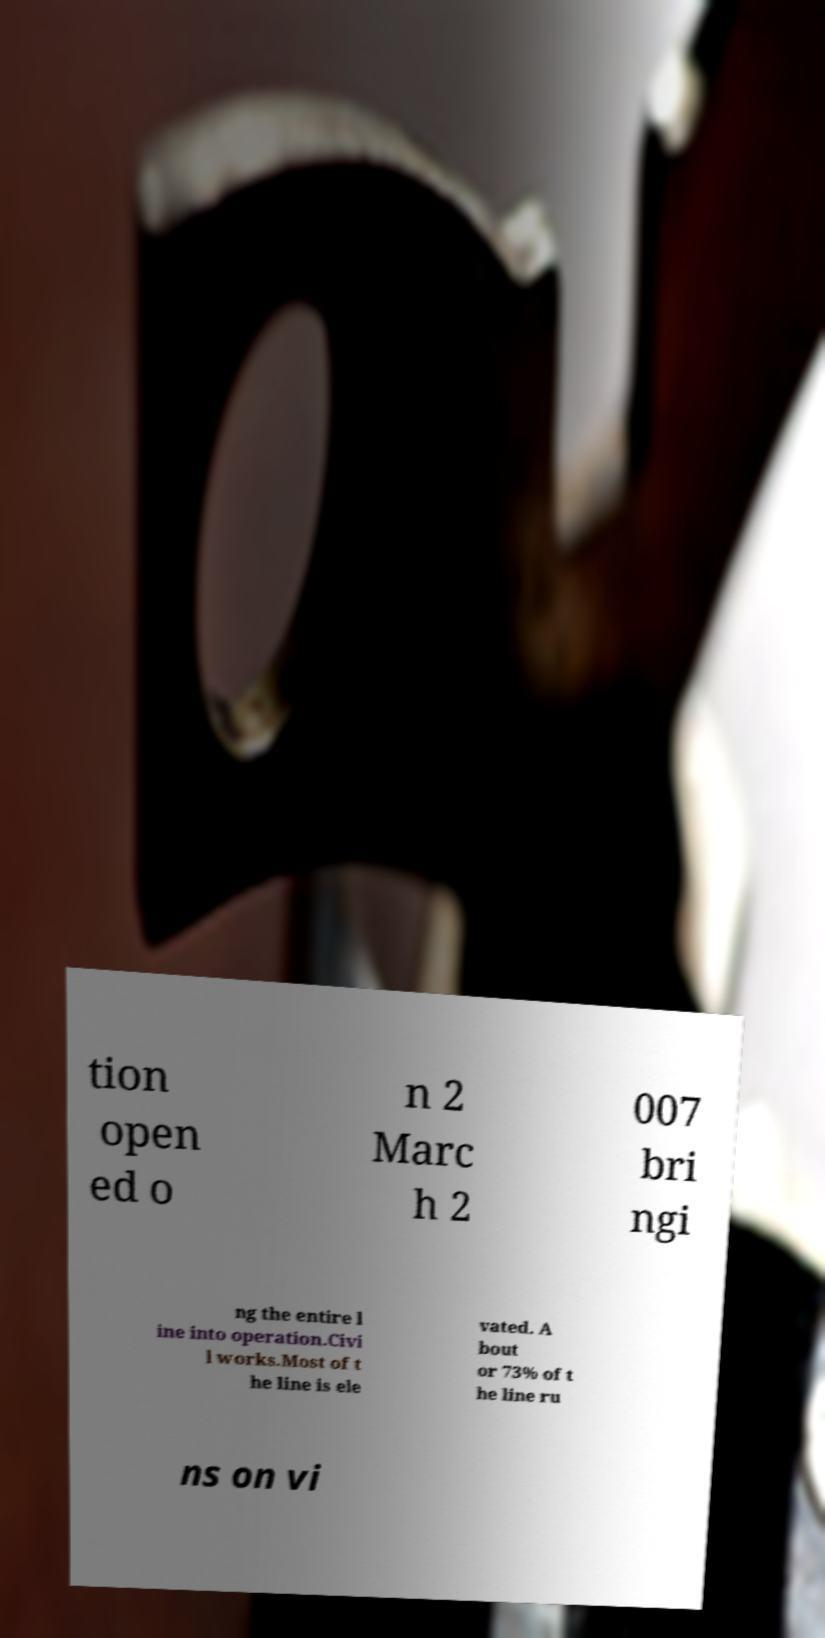There's text embedded in this image that I need extracted. Can you transcribe it verbatim? tion open ed o n 2 Marc h 2 007 bri ngi ng the entire l ine into operation.Civi l works.Most of t he line is ele vated. A bout or 73% of t he line ru ns on vi 